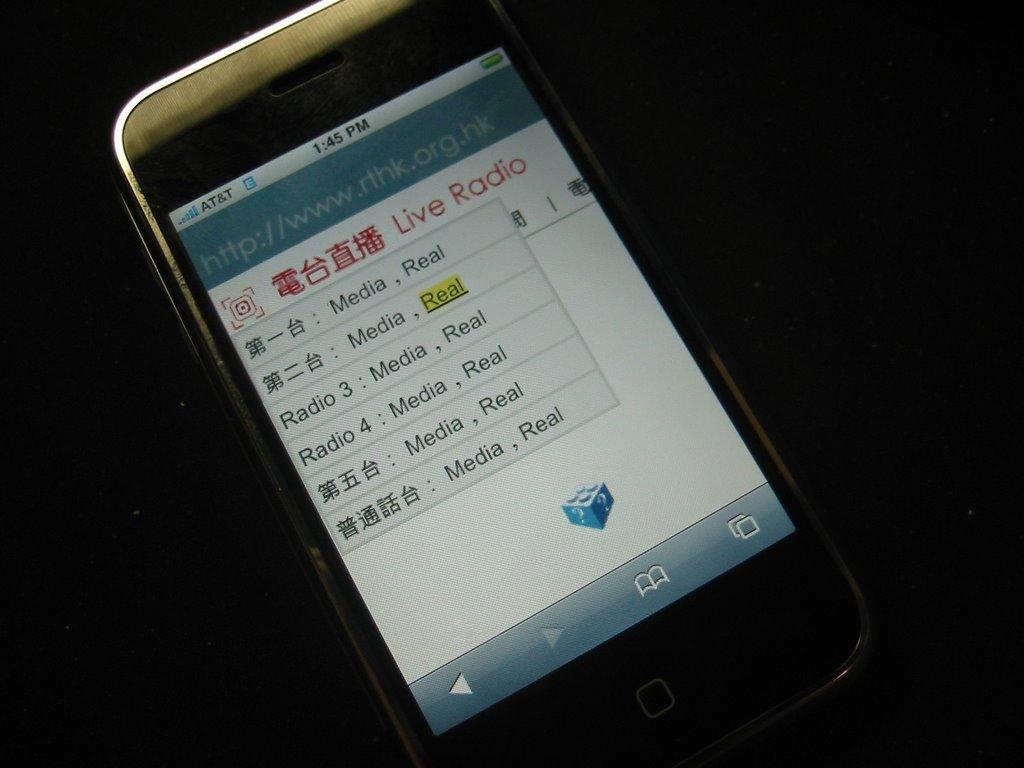<image>
Give a short and clear explanation of the subsequent image. a phone with service from at&t showing Live Radio on the screen 